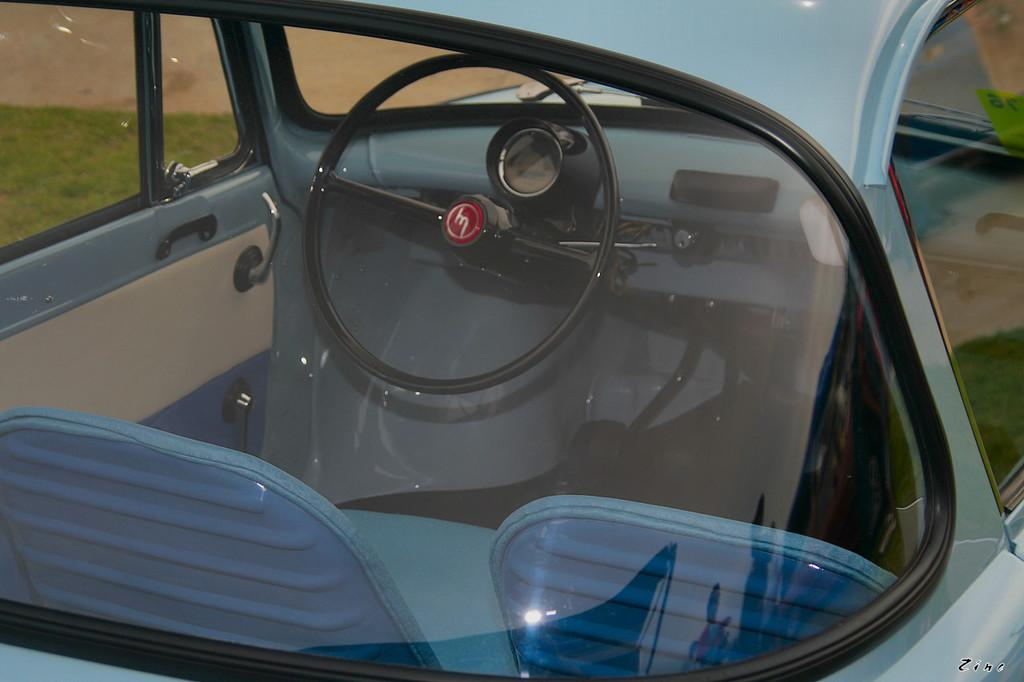What color is the vehicle in the image? The vehicle in the image is blue. What type of windows does the vehicle have? The vehicle has glass windows. What can be seen through the windows of the vehicle? The steering wheel, seats, and grass are visible through the windows. What type of band is performing on the table in the image? There is no band or table present in the image; it only features a blue vehicle with glass windows. 